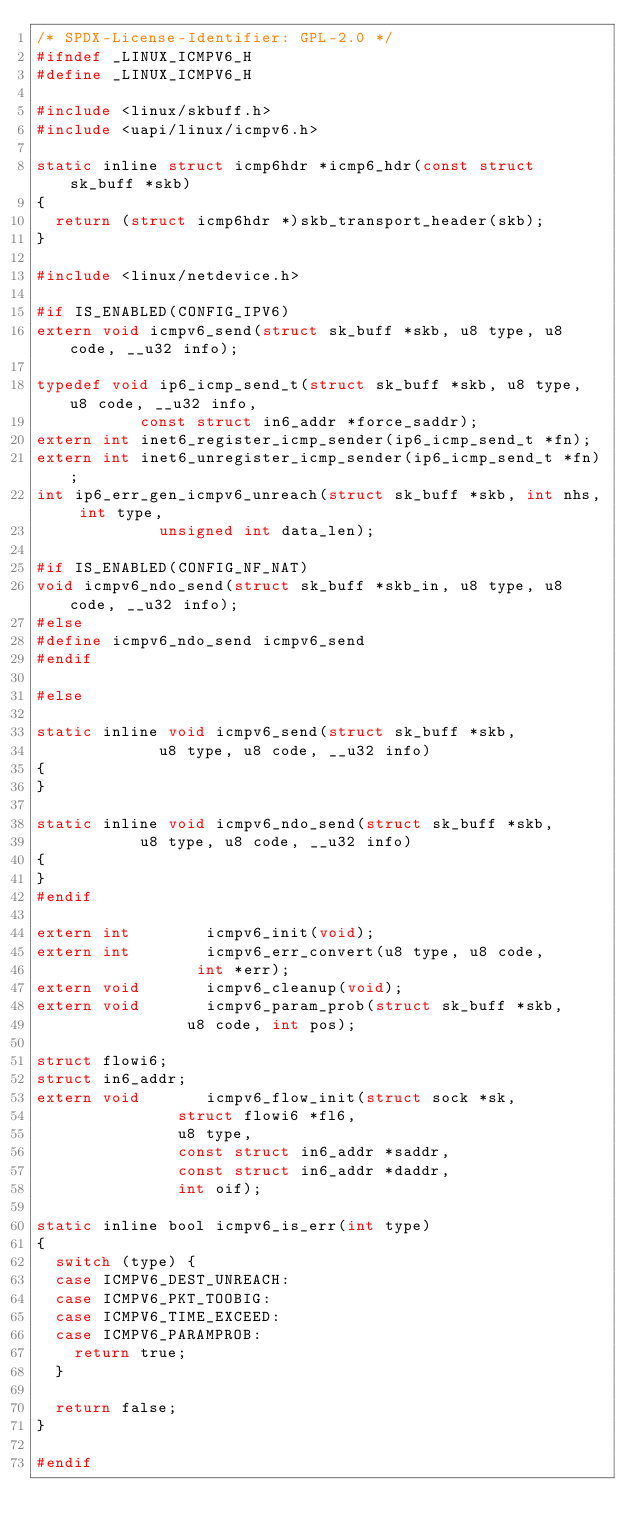Convert code to text. <code><loc_0><loc_0><loc_500><loc_500><_C_>/* SPDX-License-Identifier: GPL-2.0 */
#ifndef _LINUX_ICMPV6_H
#define _LINUX_ICMPV6_H

#include <linux/skbuff.h>
#include <uapi/linux/icmpv6.h>

static inline struct icmp6hdr *icmp6_hdr(const struct sk_buff *skb)
{
	return (struct icmp6hdr *)skb_transport_header(skb);
}

#include <linux/netdevice.h>

#if IS_ENABLED(CONFIG_IPV6)
extern void icmpv6_send(struct sk_buff *skb, u8 type, u8 code, __u32 info);

typedef void ip6_icmp_send_t(struct sk_buff *skb, u8 type, u8 code, __u32 info,
			     const struct in6_addr *force_saddr);
extern int inet6_register_icmp_sender(ip6_icmp_send_t *fn);
extern int inet6_unregister_icmp_sender(ip6_icmp_send_t *fn);
int ip6_err_gen_icmpv6_unreach(struct sk_buff *skb, int nhs, int type,
			       unsigned int data_len);

#if IS_ENABLED(CONFIG_NF_NAT)
void icmpv6_ndo_send(struct sk_buff *skb_in, u8 type, u8 code, __u32 info);
#else
#define icmpv6_ndo_send icmpv6_send
#endif

#else

static inline void icmpv6_send(struct sk_buff *skb,
			       u8 type, u8 code, __u32 info)
{
}

static inline void icmpv6_ndo_send(struct sk_buff *skb,
				   u8 type, u8 code, __u32 info)
{
}
#endif

extern int				icmpv6_init(void);
extern int				icmpv6_err_convert(u8 type, u8 code,
							   int *err);
extern void				icmpv6_cleanup(void);
extern void				icmpv6_param_prob(struct sk_buff *skb,
							  u8 code, int pos);

struct flowi6;
struct in6_addr;
extern void				icmpv6_flow_init(struct sock *sk,
							 struct flowi6 *fl6,
							 u8 type,
							 const struct in6_addr *saddr,
							 const struct in6_addr *daddr,
							 int oif);

static inline bool icmpv6_is_err(int type)
{
	switch (type) {
	case ICMPV6_DEST_UNREACH:
	case ICMPV6_PKT_TOOBIG:
	case ICMPV6_TIME_EXCEED:
	case ICMPV6_PARAMPROB:
		return true;
	}

	return false;
}

#endif
</code> 